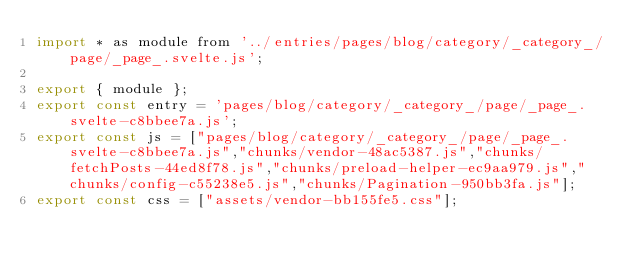<code> <loc_0><loc_0><loc_500><loc_500><_JavaScript_>import * as module from '../entries/pages/blog/category/_category_/page/_page_.svelte.js';

export { module };
export const entry = 'pages/blog/category/_category_/page/_page_.svelte-c8bbee7a.js';
export const js = ["pages/blog/category/_category_/page/_page_.svelte-c8bbee7a.js","chunks/vendor-48ac5387.js","chunks/fetchPosts-44ed8f78.js","chunks/preload-helper-ec9aa979.js","chunks/config-c55238e5.js","chunks/Pagination-950bb3fa.js"];
export const css = ["assets/vendor-bb155fe5.css"];
</code> 